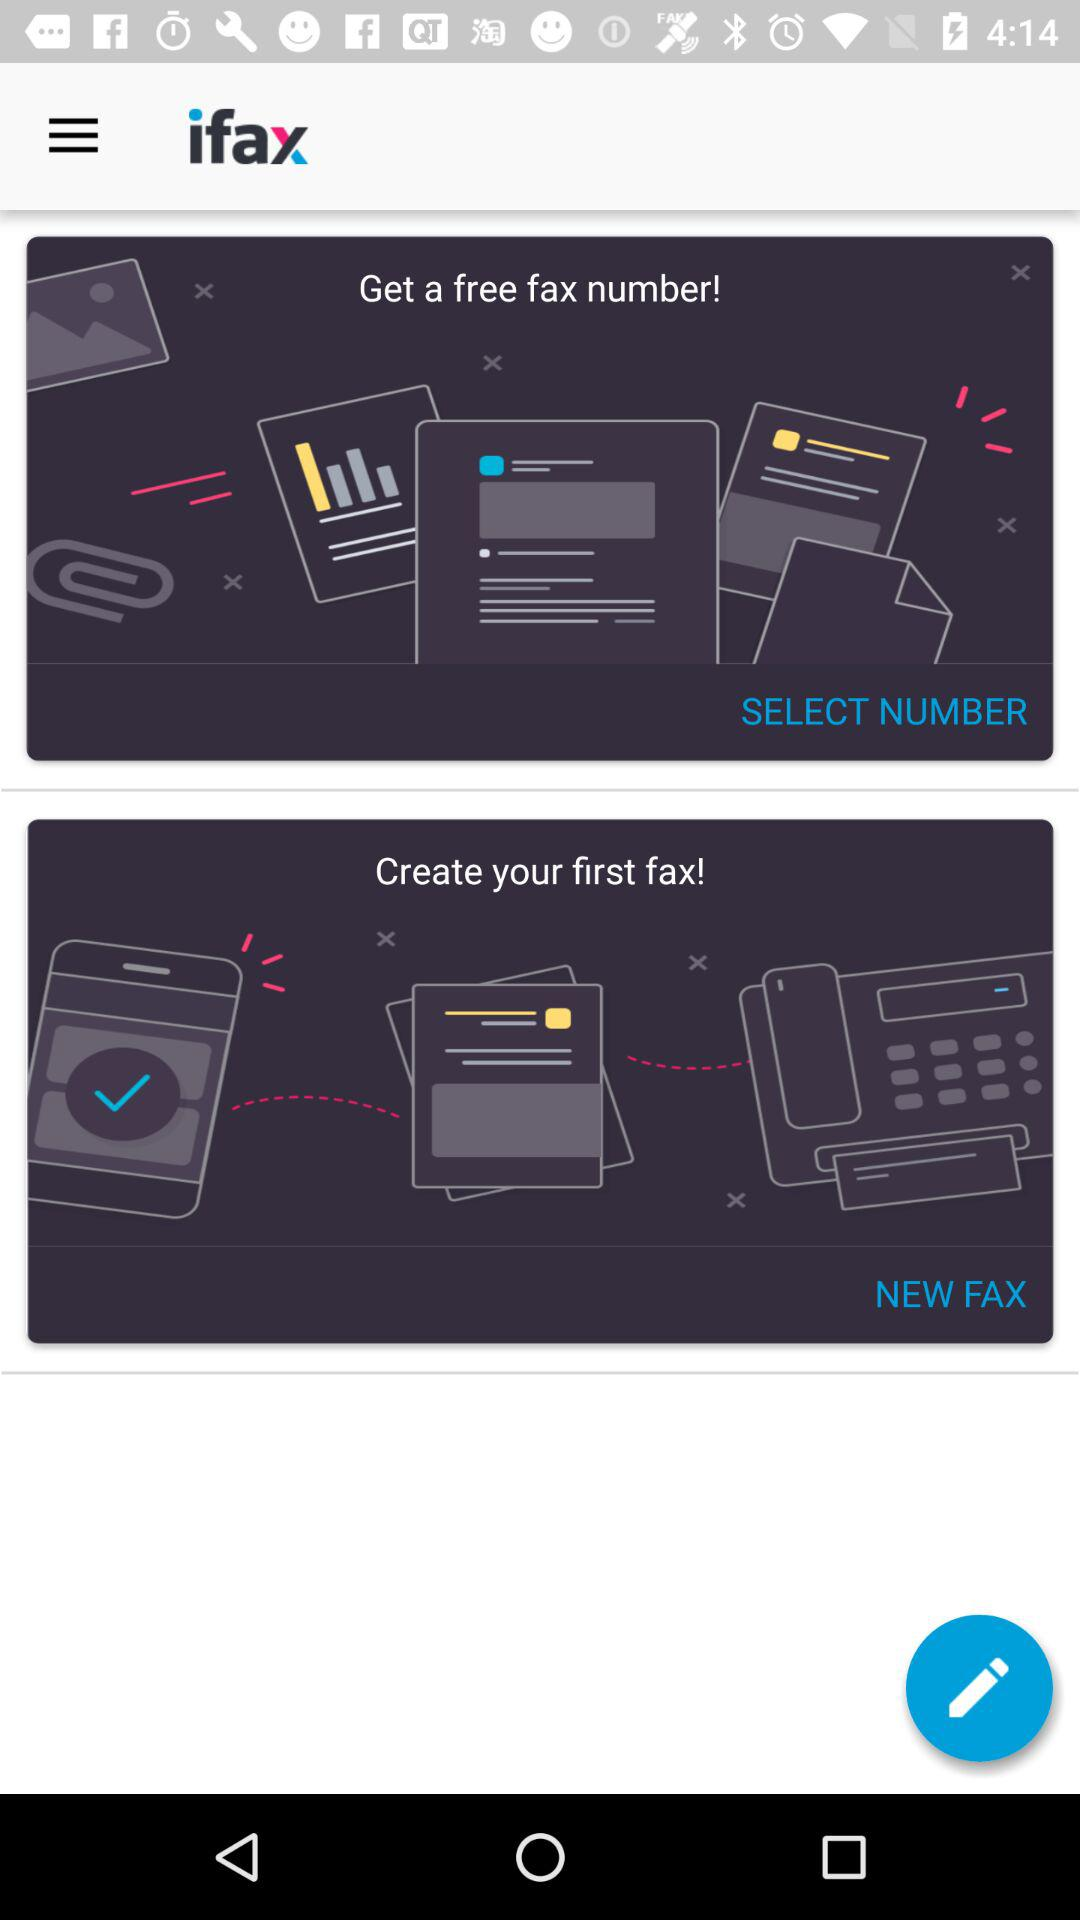What is the application name? The application name is "ifax". 